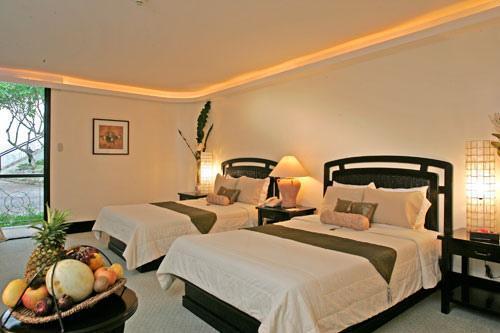What is the most likely level of this room?
Answer the question by selecting the correct answer among the 4 following choices.
Options: Basement, ground, penthouse, third. Ground. 